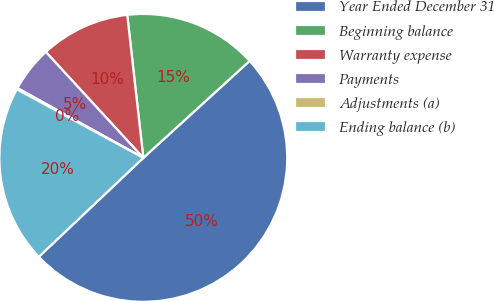Convert chart. <chart><loc_0><loc_0><loc_500><loc_500><pie_chart><fcel>Year Ended December 31<fcel>Beginning balance<fcel>Warranty expense<fcel>Payments<fcel>Adjustments (a)<fcel>Ending balance (b)<nl><fcel>49.7%<fcel>15.01%<fcel>10.06%<fcel>5.1%<fcel>0.15%<fcel>19.97%<nl></chart> 